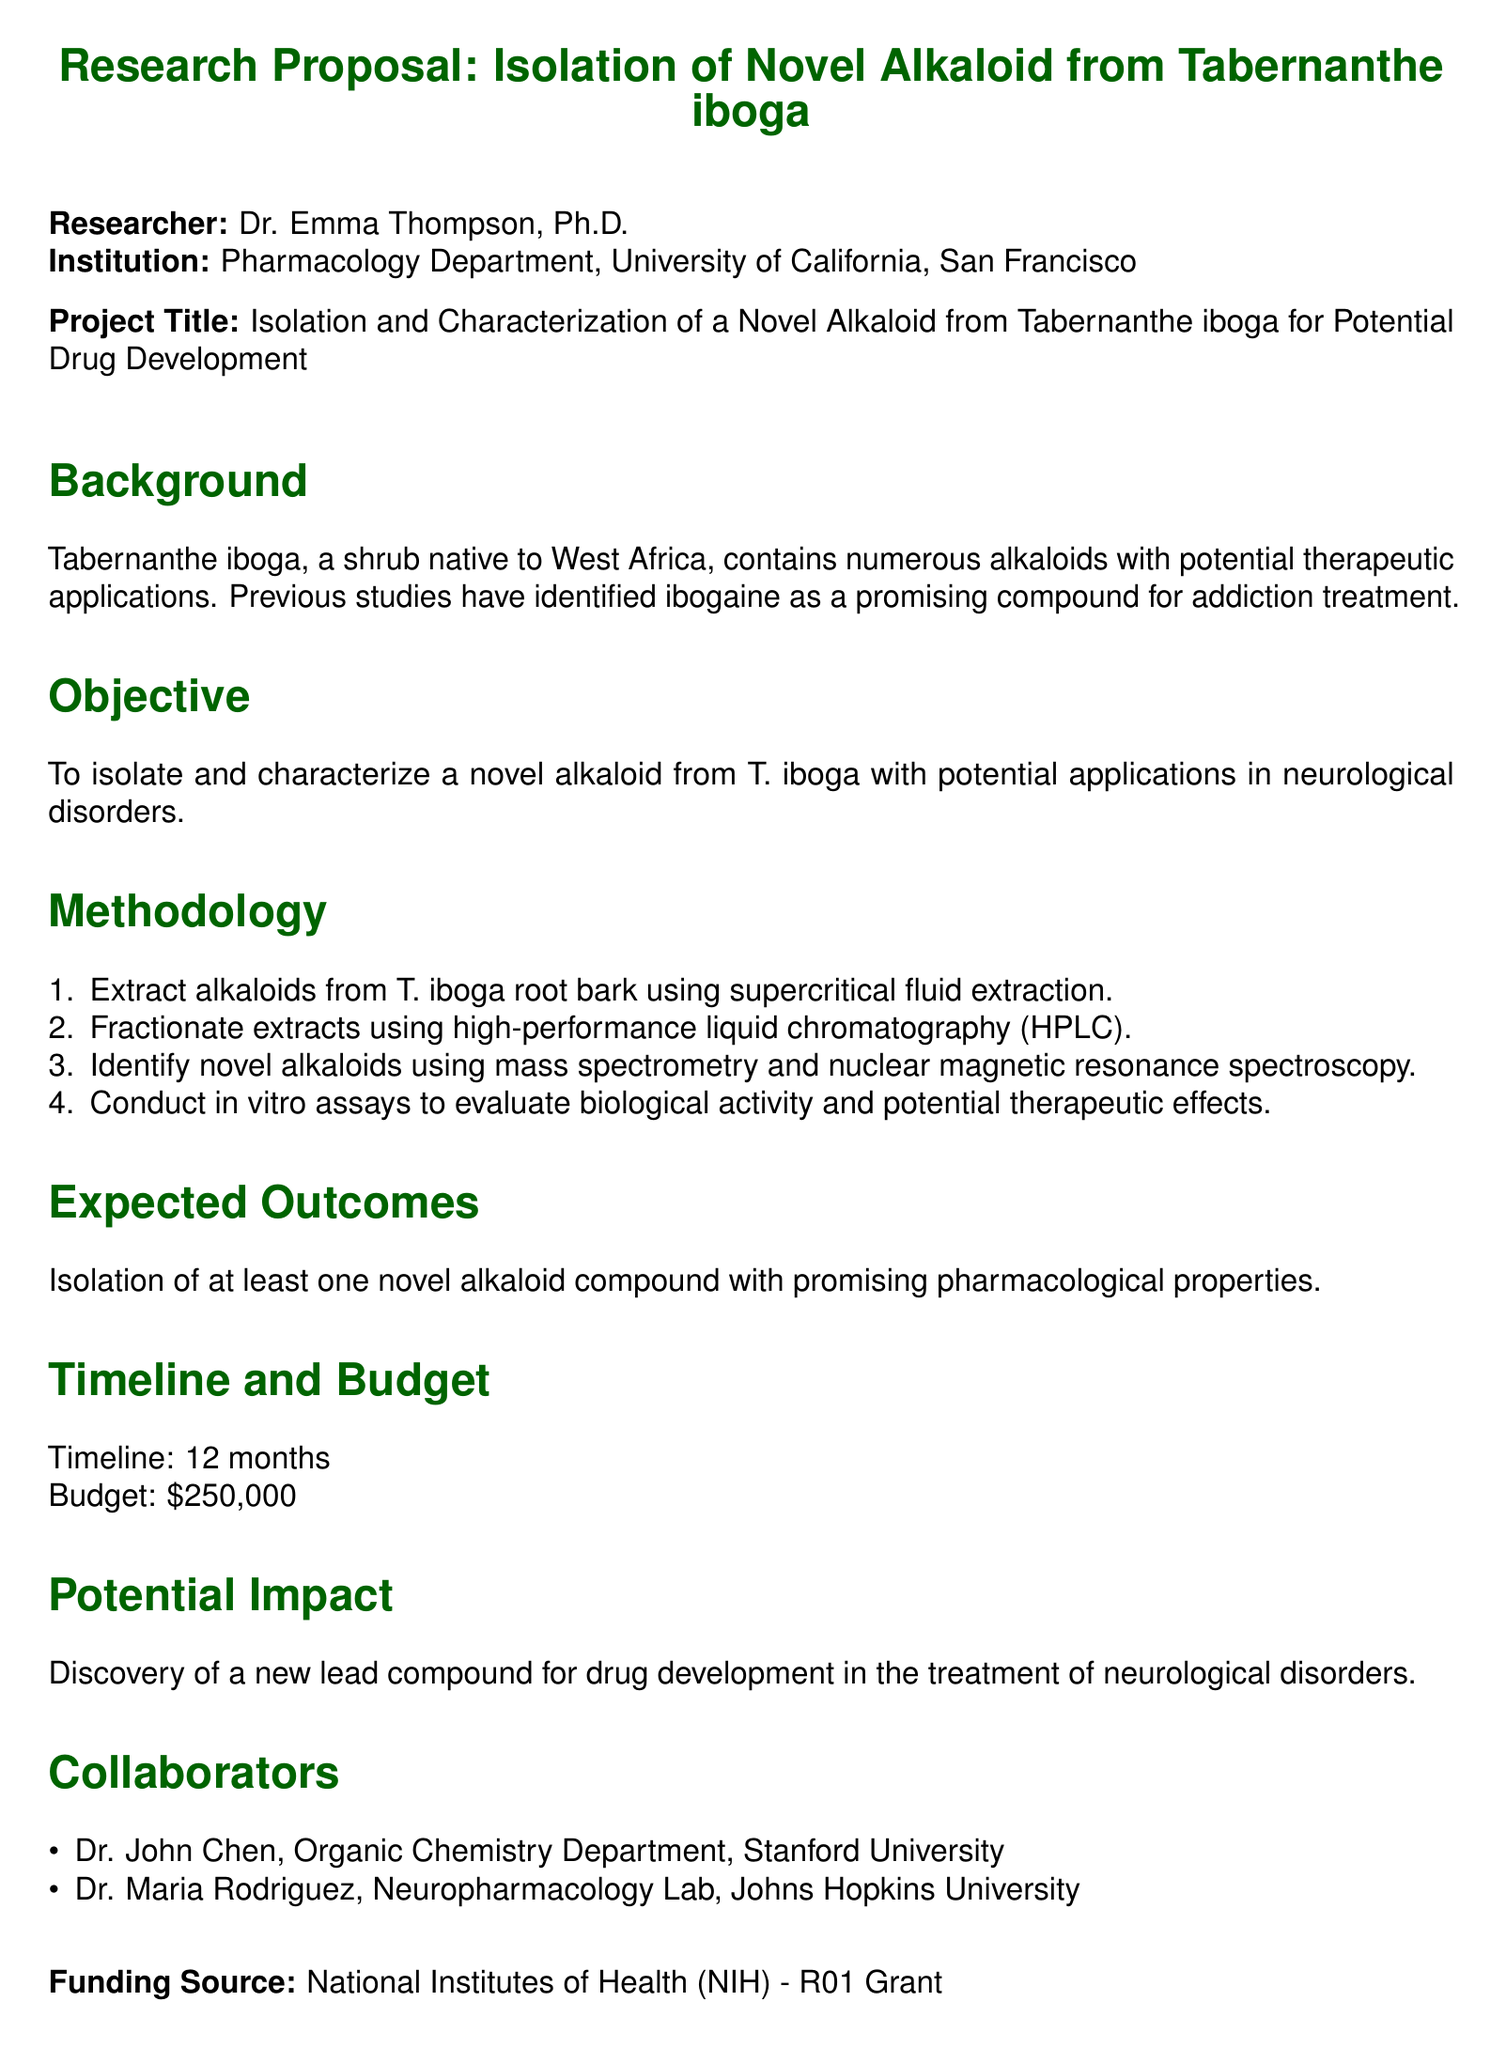What is the name of the researcher? The document specifies the researcher's name as Dr. Emma Thompson, Ph.D.
Answer: Dr. Emma Thompson, Ph.D What is the project budget? The budget for the project is stated in the document as $250,000.
Answer: $250,000 What is the timeline for the research? The document indicates that the timeline for the research is set for 12 months.
Answer: 12 months Which tropical plant species is being studied? The document mentions the tropical plant species under study is Tabernanthe iboga.
Answer: Tabernanthe iboga What extraction method will be used for alkaloids? The methodology describes supercritical fluid extraction as the technique for extracting alkaloids.
Answer: Supercritical fluid extraction Who is a collaborator from Johns Hopkins University? Dr. Maria Rodriguez is identified as a collaborator from Johns Hopkins University in the document.
Answer: Dr. Maria Rodriguez What is the primary objective of the research? The document states that the main objective is to isolate and characterize a novel alkaloid with potential applications in neurological disorders.
Answer: Isolate and characterize a novel alkaloid What funding source supports this research proposal? The document specifies the funding source as the National Institutes of Health (NIH) - R01 Grant.
Answer: National Institutes of Health (NIH) - R01 Grant What are the expected outcomes of the research? The expected outcome mentioned in the document is the isolation of at least one novel alkaloid compound with promising pharmacological properties.
Answer: At least one novel alkaloid compound with promising pharmacological properties 